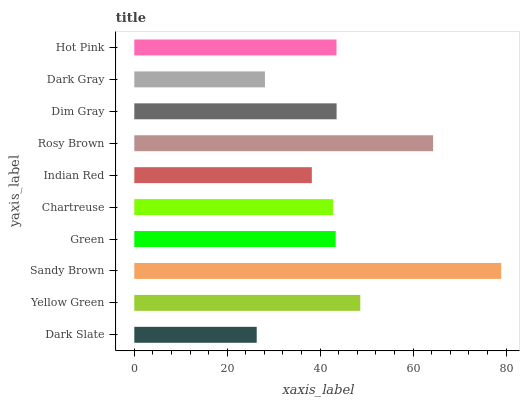Is Dark Slate the minimum?
Answer yes or no. Yes. Is Sandy Brown the maximum?
Answer yes or no. Yes. Is Yellow Green the minimum?
Answer yes or no. No. Is Yellow Green the maximum?
Answer yes or no. No. Is Yellow Green greater than Dark Slate?
Answer yes or no. Yes. Is Dark Slate less than Yellow Green?
Answer yes or no. Yes. Is Dark Slate greater than Yellow Green?
Answer yes or no. No. Is Yellow Green less than Dark Slate?
Answer yes or no. No. Is Hot Pink the high median?
Answer yes or no. Yes. Is Green the low median?
Answer yes or no. Yes. Is Green the high median?
Answer yes or no. No. Is Dark Gray the low median?
Answer yes or no. No. 